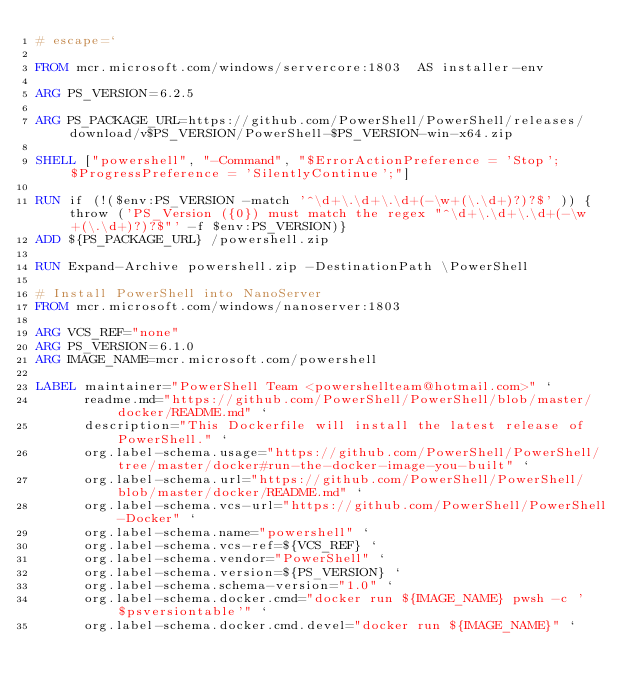<code> <loc_0><loc_0><loc_500><loc_500><_Dockerfile_># escape=`

FROM mcr.microsoft.com/windows/servercore:1803  AS installer-env

ARG PS_VERSION=6.2.5

ARG PS_PACKAGE_URL=https://github.com/PowerShell/PowerShell/releases/download/v$PS_VERSION/PowerShell-$PS_VERSION-win-x64.zip

SHELL ["powershell", "-Command", "$ErrorActionPreference = 'Stop'; $ProgressPreference = 'SilentlyContinue';"]

RUN if (!($env:PS_VERSION -match '^\d+\.\d+\.\d+(-\w+(\.\d+)?)?$' )) {throw ('PS_Version ({0}) must match the regex "^\d+\.\d+\.\d+(-\w+(\.\d+)?)?$"' -f $env:PS_VERSION)}
ADD ${PS_PACKAGE_URL} /powershell.zip

RUN Expand-Archive powershell.zip -DestinationPath \PowerShell

# Install PowerShell into NanoServer
FROM mcr.microsoft.com/windows/nanoserver:1803

ARG VCS_REF="none"
ARG PS_VERSION=6.1.0
ARG IMAGE_NAME=mcr.microsoft.com/powershell

LABEL maintainer="PowerShell Team <powershellteam@hotmail.com>" `
      readme.md="https://github.com/PowerShell/PowerShell/blob/master/docker/README.md" `
      description="This Dockerfile will install the latest release of PowerShell." `
      org.label-schema.usage="https://github.com/PowerShell/PowerShell/tree/master/docker#run-the-docker-image-you-built" `
      org.label-schema.url="https://github.com/PowerShell/PowerShell/blob/master/docker/README.md" `
      org.label-schema.vcs-url="https://github.com/PowerShell/PowerShell-Docker" `
      org.label-schema.name="powershell" `
      org.label-schema.vcs-ref=${VCS_REF} `
      org.label-schema.vendor="PowerShell" `
      org.label-schema.version=${PS_VERSION} `
      org.label-schema.schema-version="1.0" `
      org.label-schema.docker.cmd="docker run ${IMAGE_NAME} pwsh -c '$psversiontable'" `
      org.label-schema.docker.cmd.devel="docker run ${IMAGE_NAME}" `</code> 